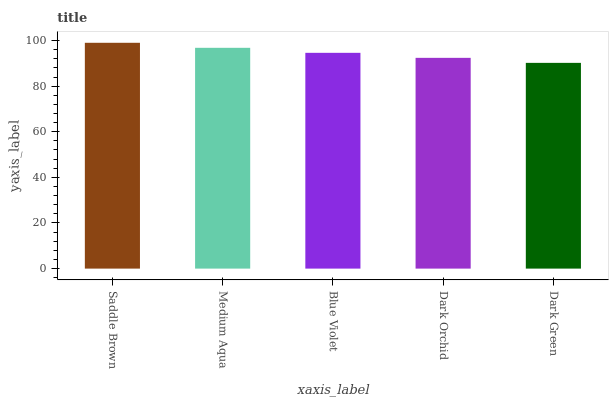Is Dark Green the minimum?
Answer yes or no. Yes. Is Saddle Brown the maximum?
Answer yes or no. Yes. Is Medium Aqua the minimum?
Answer yes or no. No. Is Medium Aqua the maximum?
Answer yes or no. No. Is Saddle Brown greater than Medium Aqua?
Answer yes or no. Yes. Is Medium Aqua less than Saddle Brown?
Answer yes or no. Yes. Is Medium Aqua greater than Saddle Brown?
Answer yes or no. No. Is Saddle Brown less than Medium Aqua?
Answer yes or no. No. Is Blue Violet the high median?
Answer yes or no. Yes. Is Blue Violet the low median?
Answer yes or no. Yes. Is Medium Aqua the high median?
Answer yes or no. No. Is Saddle Brown the low median?
Answer yes or no. No. 